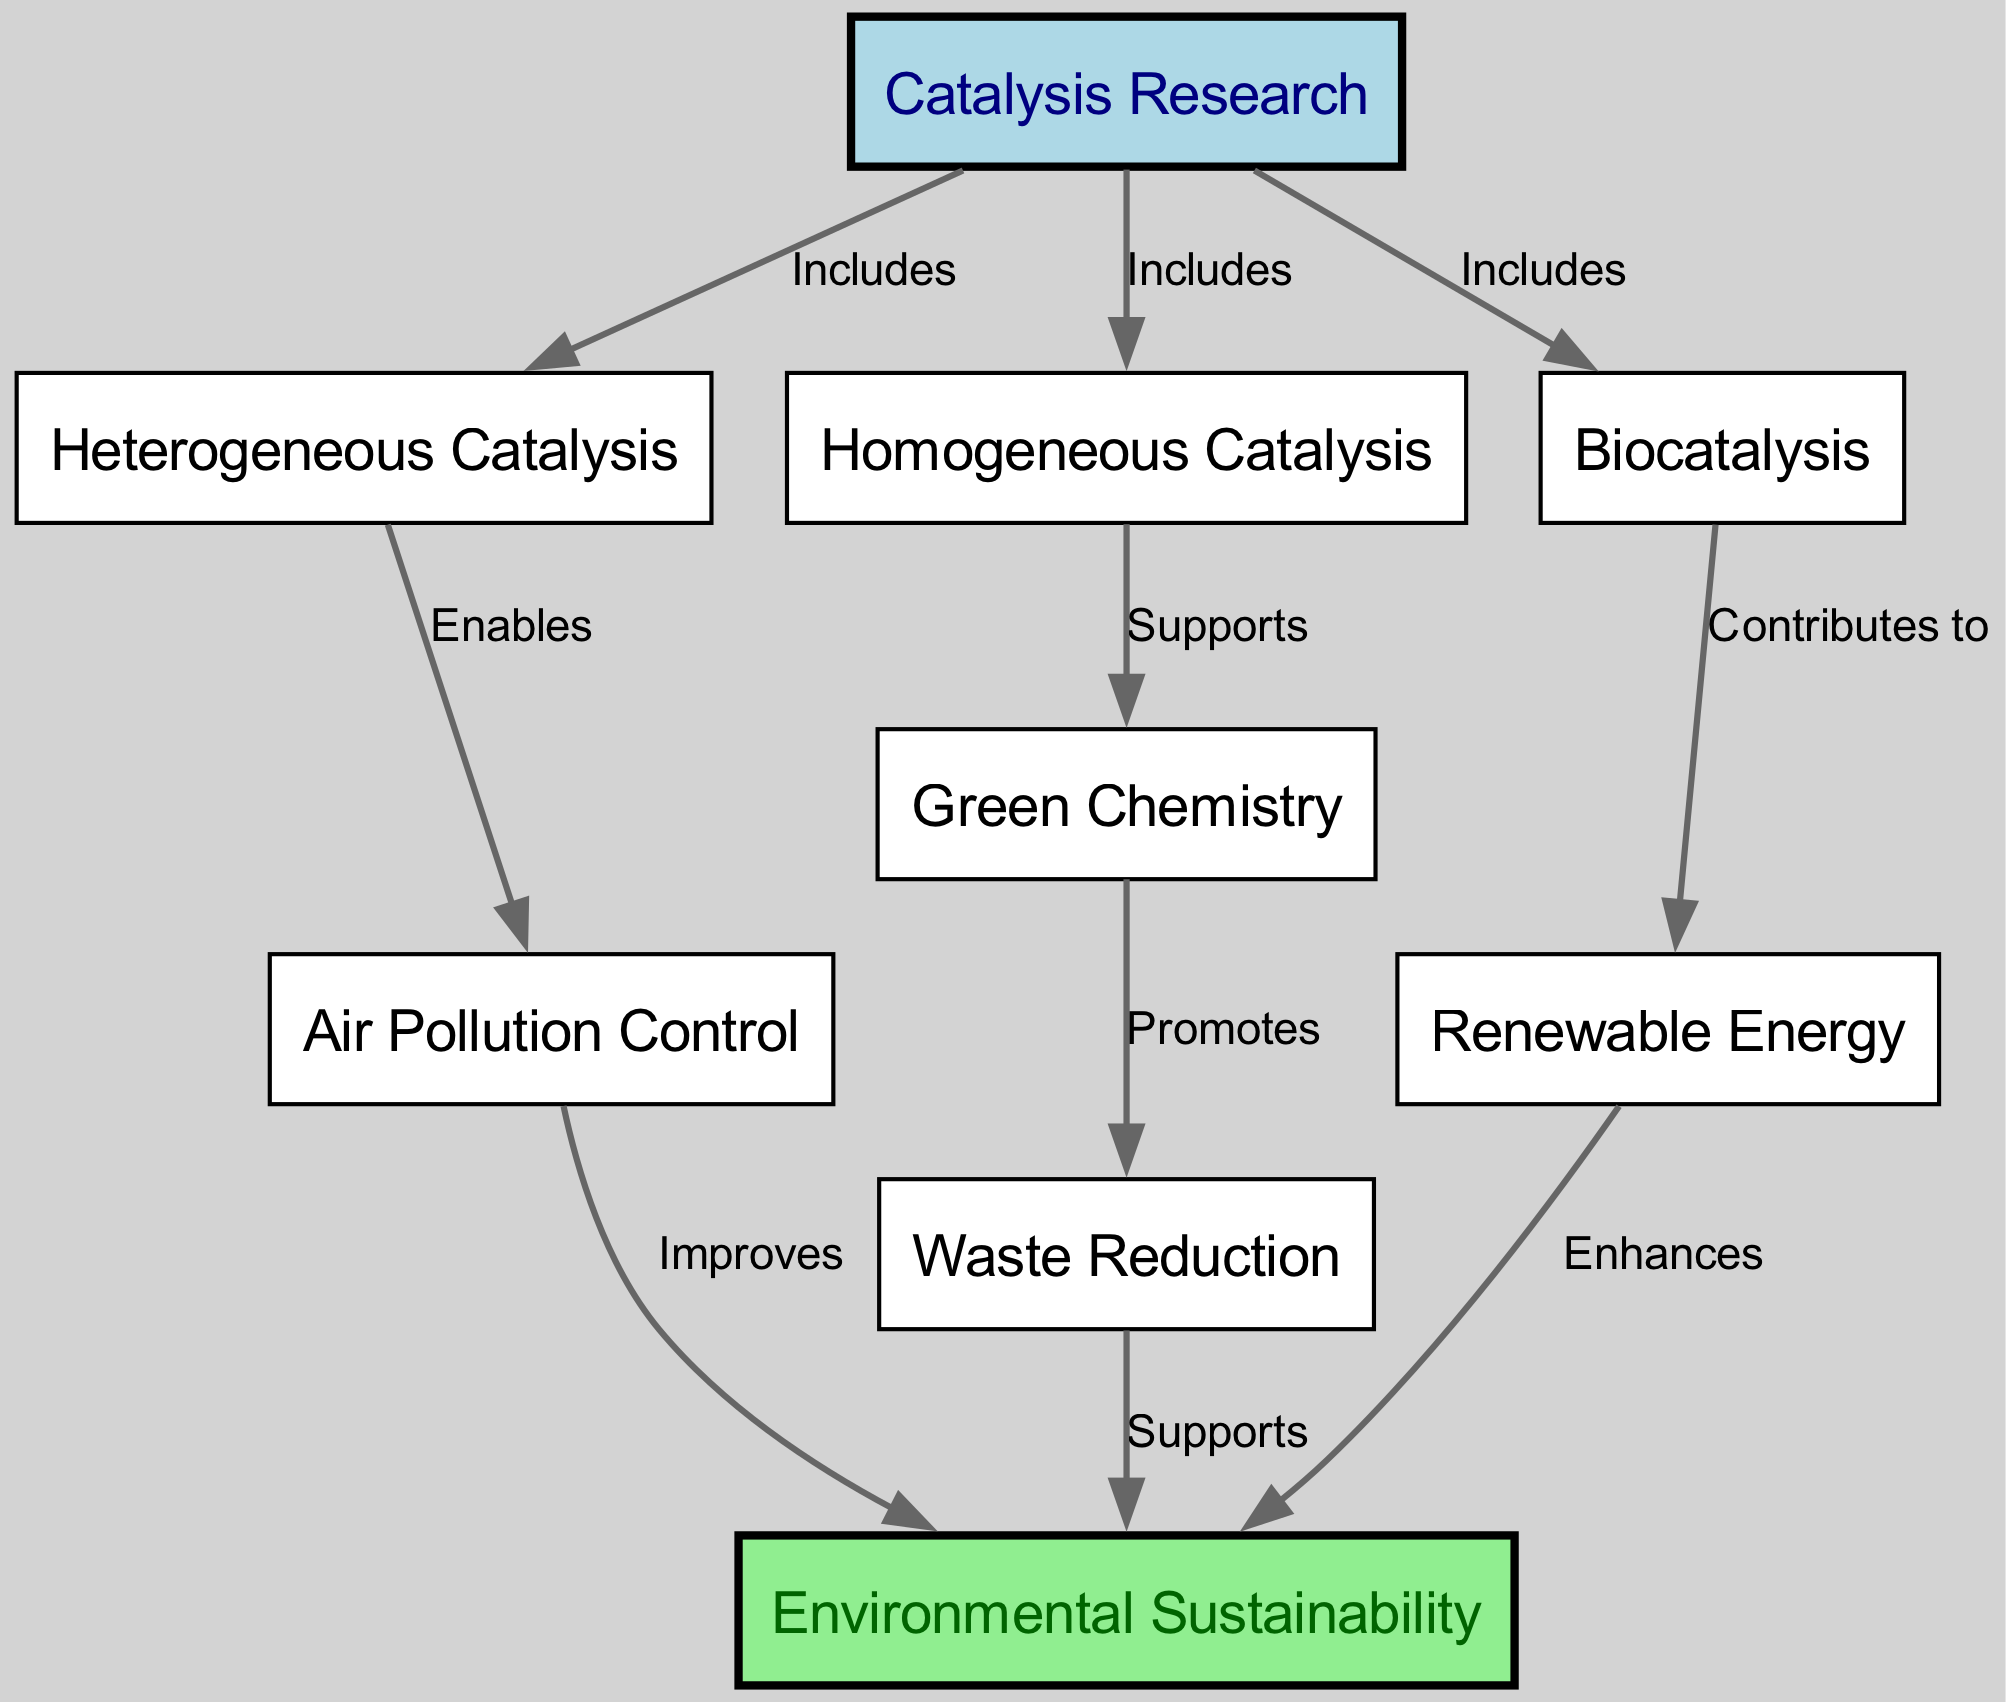What are the three types of catalysis included in catalysis research? The diagram displays three nodes connected to the main node "Catalysis Research" with the label "Includes". They are "Heterogeneous Catalysis", "Homogeneous Catalysis", and "Biocatalysis".
Answer: Heterogeneous Catalysis, Homogeneous Catalysis, Biocatalysis Which concept directly promotes waste reduction? The diagram indicates an arrow from "Green Chemistry" to "Waste Reduction" labeled "Promotes", showing that "Green Chemistry" promotes the "Waste Reduction" concept.
Answer: Green Chemistry How many edges are present in this diagram? Counting the relationships (edges) that connect the nodes reveals there are ten edges in total in the diagram.
Answer: 10 What area contributes to renewable energy? The diagram shows "Biocatalysis" with a directed edge to "Renewable Energy" labeled "Contributes to," indicating that biocatalysis contributes to renewable energy.
Answer: Biocatalysis Which two factors improve environmental sustainability? The diagram shows connections from "Air Pollution Control" and "Renewable Energy" to "Environmental Sustainability," both labeled "Improves" and "Enhances," respectively, indicating their roles in improving sustainability.
Answer: Air Pollution Control, Renewable Energy Which types of catalysis support green chemistry? The diagram links "Homogeneous Catalysis" to "Green Chemistry" with the label "Supports," suggesting that homogeneous catalysis supports green chemistry but does not mention any other type directly supporting it in the diagram.
Answer: Homogeneous Catalysis Which concept is central to the diagram showing the relationship between catalysis and environmental sustainability? The diagram's main focus is "Catalysis Research," connecting various forms of catalysis to their impact on environmental sustainability, making it the central concept of the diagram.
Answer: Catalysis Research What label indicates that heterogeneous catalysis enables air pollution control? The relationship between "Heterogeneous Catalysis" and "Air Pollution Control" is labeled "Enables," which clearly communicates the nature of this connection in the diagram.
Answer: Enables How does waste reduction support environmental sustainability? "Waste Reduction" has a directed edge towards "Environmental Sustainability" labeled "Supports." This indicates that waste reduction aids in achieving environmental sustainability in the context of the diagram.
Answer: Supports 